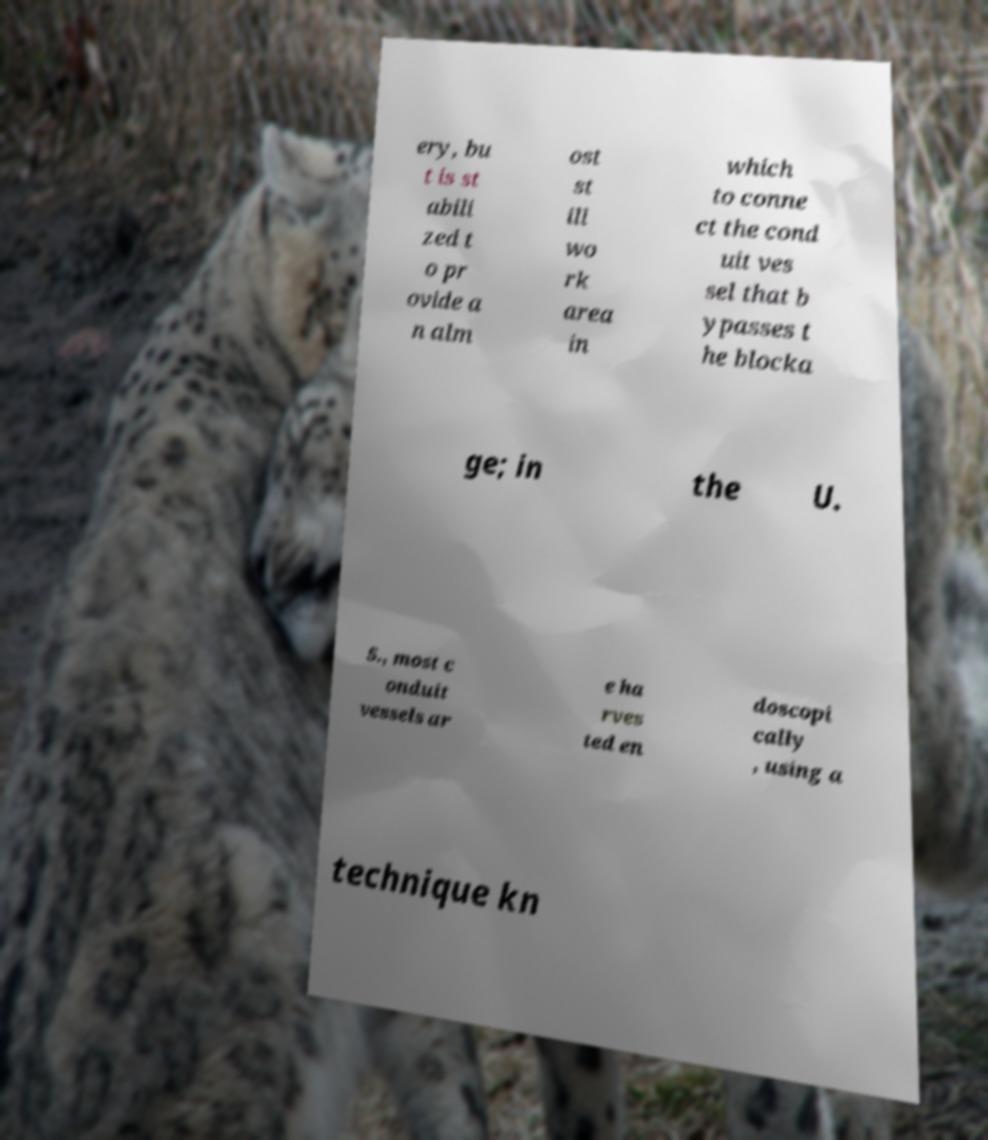Can you read and provide the text displayed in the image?This photo seems to have some interesting text. Can you extract and type it out for me? ery, bu t is st abili zed t o pr ovide a n alm ost st ill wo rk area in which to conne ct the cond uit ves sel that b ypasses t he blocka ge; in the U. S., most c onduit vessels ar e ha rves ted en doscopi cally , using a technique kn 